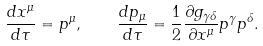Convert formula to latex. <formula><loc_0><loc_0><loc_500><loc_500>\frac { d x ^ { \mu } } { d \tau } = p ^ { \mu } , \quad \frac { d p _ { \mu } } { d \tau } = \frac { 1 } { 2 } \frac { \partial g _ { \gamma \delta } } { \partial x ^ { \mu } } p ^ { \gamma } p ^ { \delta } .</formula> 